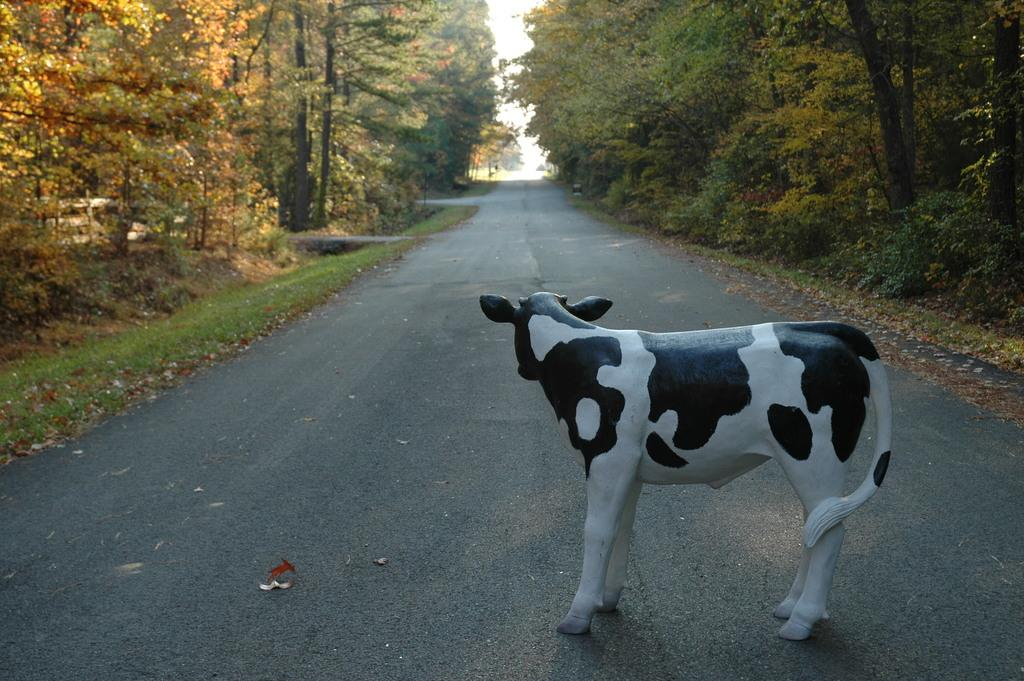What type of animal is depicted in the statue in the image? There is a statue of a lamb or a cow in the image. In which direction is the statue facing? The statue is facing towards the back. Where is the statue located? The statue is on the road. What can be seen on both sides of the road? There are trees on both sides of the road. What type of desk can be seen in the image? There is no desk present in the image; it features a statue of a lamb or a cow on the road with trees on both sides. 